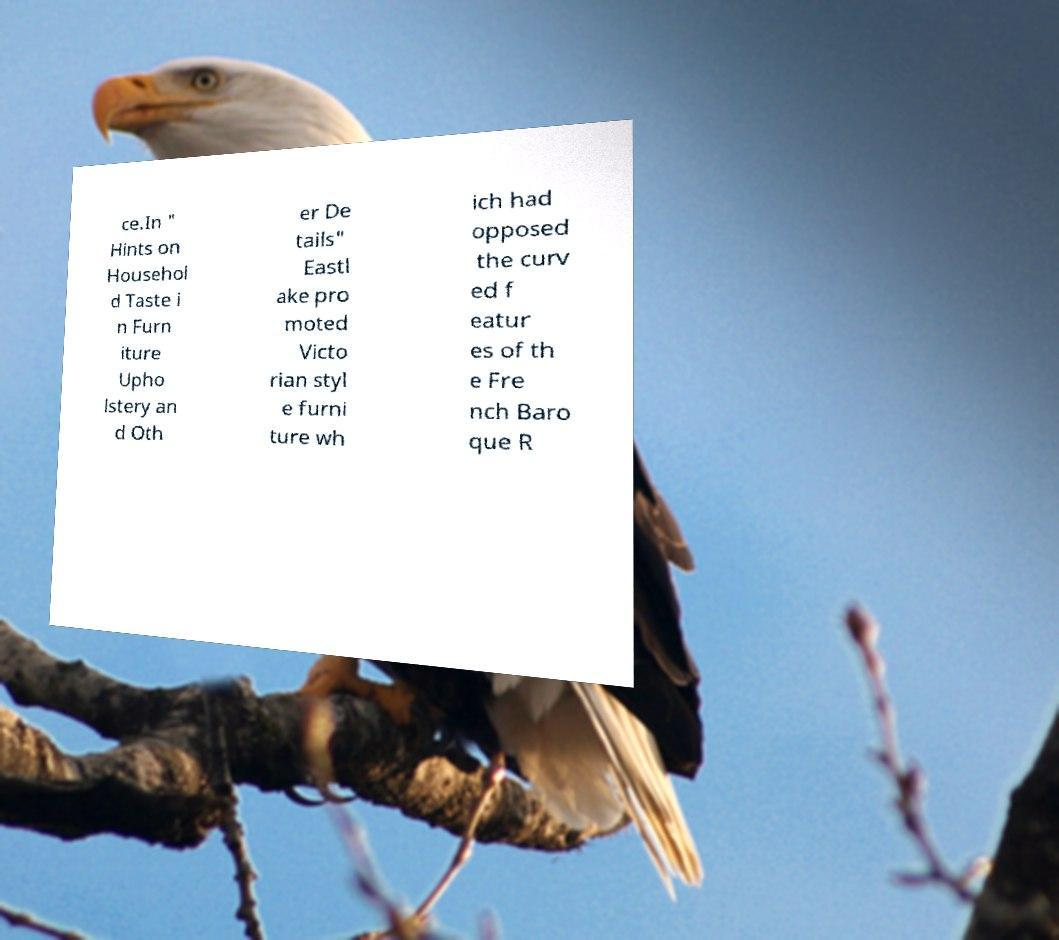There's text embedded in this image that I need extracted. Can you transcribe it verbatim? ce.In " Hints on Househol d Taste i n Furn iture Upho lstery an d Oth er De tails" Eastl ake pro moted Victo rian styl e furni ture wh ich had opposed the curv ed f eatur es of th e Fre nch Baro que R 